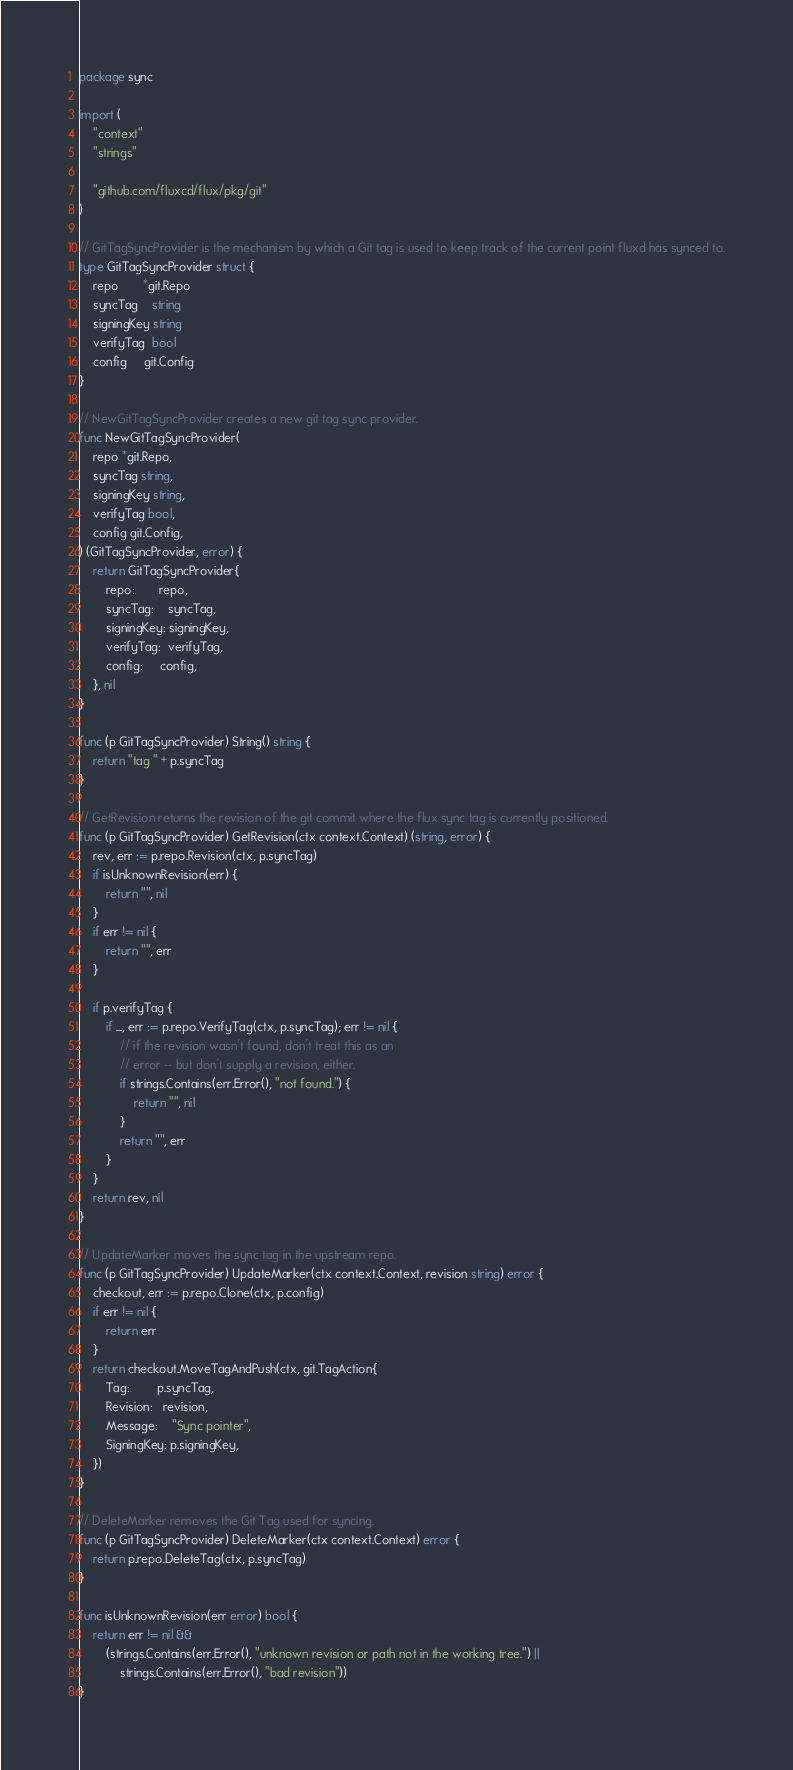Convert code to text. <code><loc_0><loc_0><loc_500><loc_500><_Go_>package sync

import (
	"context"
	"strings"

	"github.com/fluxcd/flux/pkg/git"
)

// GitTagSyncProvider is the mechanism by which a Git tag is used to keep track of the current point fluxd has synced to.
type GitTagSyncProvider struct {
	repo       *git.Repo
	syncTag    string
	signingKey string
	verifyTag  bool
	config     git.Config
}

// NewGitTagSyncProvider creates a new git tag sync provider.
func NewGitTagSyncProvider(
	repo *git.Repo,
	syncTag string,
	signingKey string,
	verifyTag bool,
	config git.Config,
) (GitTagSyncProvider, error) {
	return GitTagSyncProvider{
		repo:       repo,
		syncTag:    syncTag,
		signingKey: signingKey,
		verifyTag:  verifyTag,
		config:     config,
	}, nil
}

func (p GitTagSyncProvider) String() string {
	return "tag " + p.syncTag
}

// GetRevision returns the revision of the git commit where the flux sync tag is currently positioned.
func (p GitTagSyncProvider) GetRevision(ctx context.Context) (string, error) {
	rev, err := p.repo.Revision(ctx, p.syncTag)
	if isUnknownRevision(err) {
		return "", nil
	}
	if err != nil {
		return "", err
	}

	if p.verifyTag {
		if _, err := p.repo.VerifyTag(ctx, p.syncTag); err != nil {
			// if the revision wasn't found, don't treat this as an
			// error -- but don't supply a revision, either.
			if strings.Contains(err.Error(), "not found.") {
				return "", nil
			}
			return "", err
		}
	}
	return rev, nil
}

// UpdateMarker moves the sync tag in the upstream repo.
func (p GitTagSyncProvider) UpdateMarker(ctx context.Context, revision string) error {
	checkout, err := p.repo.Clone(ctx, p.config)
	if err != nil {
		return err
	}
	return checkout.MoveTagAndPush(ctx, git.TagAction{
		Tag:        p.syncTag,
		Revision:   revision,
		Message:    "Sync pointer",
		SigningKey: p.signingKey,
	})
}

// DeleteMarker removes the Git Tag used for syncing.
func (p GitTagSyncProvider) DeleteMarker(ctx context.Context) error {
	return p.repo.DeleteTag(ctx, p.syncTag)
}

func isUnknownRevision(err error) bool {
	return err != nil &&
		(strings.Contains(err.Error(), "unknown revision or path not in the working tree.") ||
			strings.Contains(err.Error(), "bad revision"))
}
</code> 